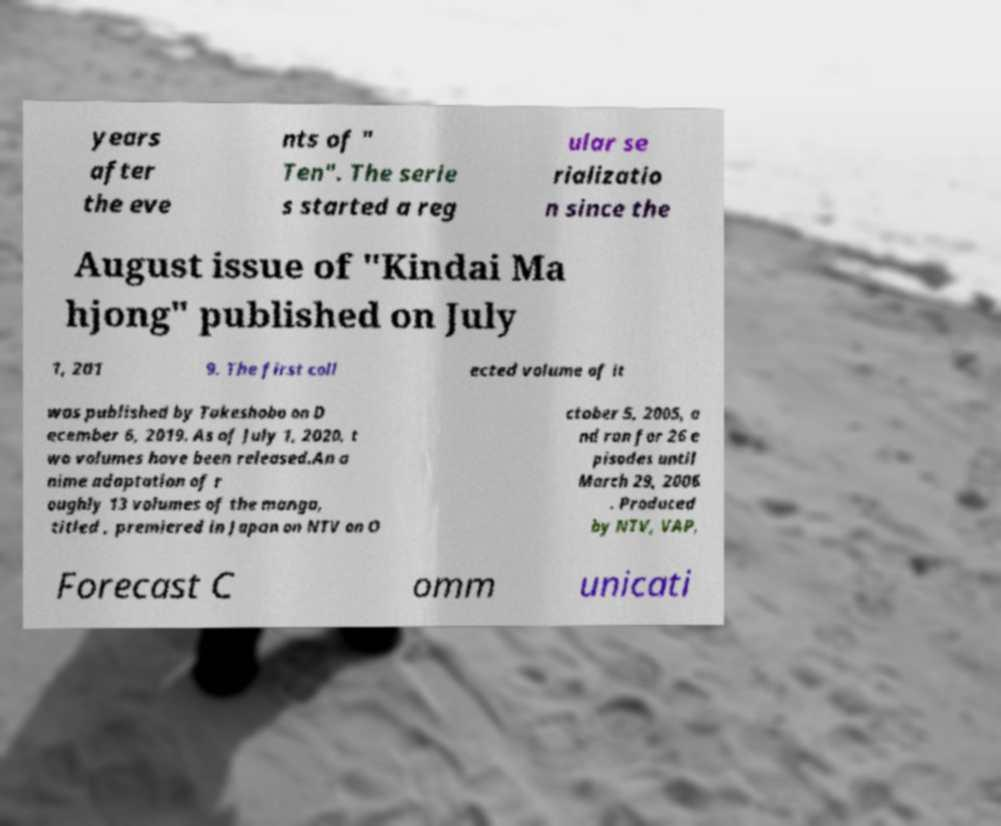Can you read and provide the text displayed in the image?This photo seems to have some interesting text. Can you extract and type it out for me? years after the eve nts of " Ten". The serie s started a reg ular se rializatio n since the August issue of "Kindai Ma hjong" published on July 1, 201 9. The first coll ected volume of it was published by Takeshobo on D ecember 6, 2019. As of July 1, 2020, t wo volumes have been released.An a nime adaptation of r oughly 13 volumes of the manga, titled , premiered in Japan on NTV on O ctober 5, 2005, a nd ran for 26 e pisodes until March 29, 2006 . Produced by NTV, VAP, Forecast C omm unicati 